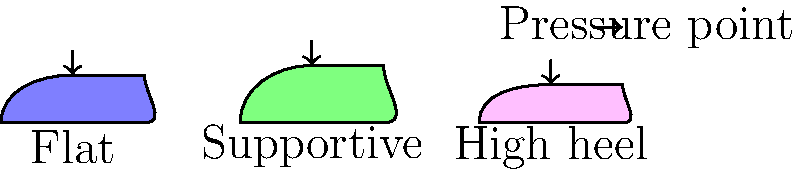Based on the diagram showing different shoe types and their pressure points, which shoe design is likely to cause the least foot and leg fatigue during long shifts on a factory floor? To determine which shoe design will cause the least foot and leg fatigue during long shifts, we need to consider the following factors:

1. Pressure distribution: Even distribution of pressure reduces fatigue.
2. Support: Proper support helps maintain good posture and reduces strain.
3. Heel height: Lower heels generally cause less fatigue than high heels.

Analyzing the diagram:

1. Flat shoe:
   - Even pressure distribution across the foot
   - Lacks arch support
   - May not provide enough cushioning

2. Supportive shoe:
   - Slightly elevated heel for better posture
   - Provides arch support
   - Pressure is distributed more evenly

3. High heel shoe:
   - Concentrates pressure on the ball of the foot and heel
   - Alters natural posture, increasing strain on legs and back
   - Least suitable for long periods of standing

The supportive shoe design offers the best combination of pressure distribution, support, and heel height. It provides arch support to maintain proper foot alignment, has a slight heel elevation to promote good posture, and distributes pressure more evenly across the foot.

Therefore, the supportive shoe design is likely to cause the least foot and leg fatigue during long shifts on a factory floor.
Answer: Supportive shoe design 